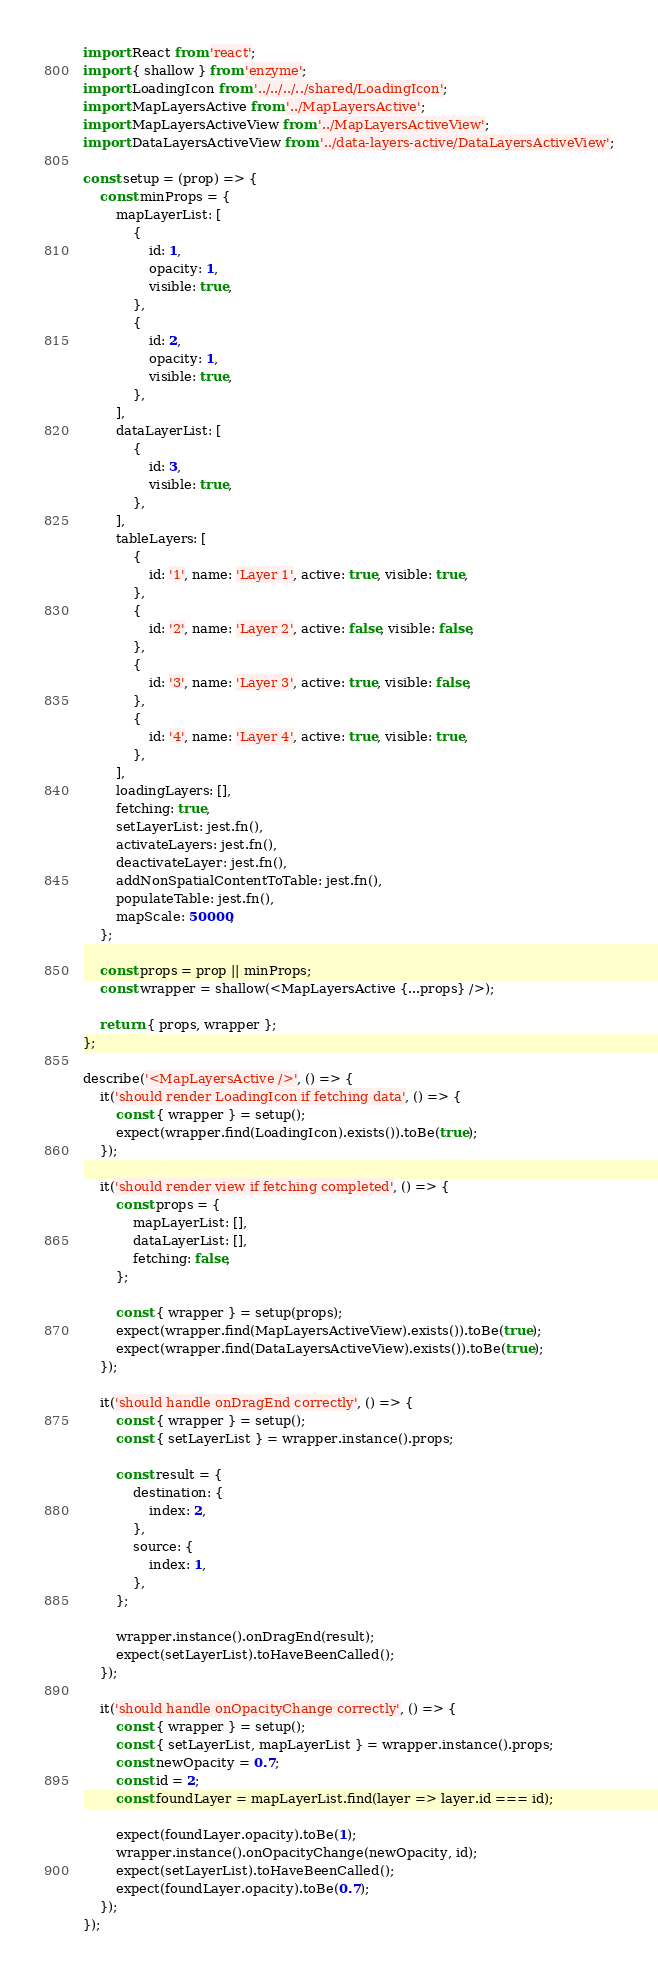<code> <loc_0><loc_0><loc_500><loc_500><_JavaScript_>import React from 'react';
import { shallow } from 'enzyme';
import LoadingIcon from '../../../../shared/LoadingIcon';
import MapLayersActive from '../MapLayersActive';
import MapLayersActiveView from '../MapLayersActiveView';
import DataLayersActiveView from '../data-layers-active/DataLayersActiveView';

const setup = (prop) => {
    const minProps = {
        mapLayerList: [
            {
                id: 1,
                opacity: 1,
                visible: true,
            },
            {
                id: 2,
                opacity: 1,
                visible: true,
            },
        ],
        dataLayerList: [
            {
                id: 3,
                visible: true,
            },
        ],
        tableLayers: [
            {
                id: '1', name: 'Layer 1', active: true, visible: true,
            },
            {
                id: '2', name: 'Layer 2', active: false, visible: false,
            },
            {
                id: '3', name: 'Layer 3', active: true, visible: false,
            },
            {
                id: '4', name: 'Layer 4', active: true, visible: true,
            },
        ],
        loadingLayers: [],
        fetching: true,
        setLayerList: jest.fn(),
        activateLayers: jest.fn(),
        deactivateLayer: jest.fn(),
        addNonSpatialContentToTable: jest.fn(),
        populateTable: jest.fn(),
        mapScale: 50000,
    };

    const props = prop || minProps;
    const wrapper = shallow(<MapLayersActive {...props} />);

    return { props, wrapper };
};

describe('<MapLayersActive />', () => {
    it('should render LoadingIcon if fetching data', () => {
        const { wrapper } = setup();
        expect(wrapper.find(LoadingIcon).exists()).toBe(true);
    });

    it('should render view if fetching completed', () => {
        const props = {
            mapLayerList: [],
            dataLayerList: [],
            fetching: false,
        };

        const { wrapper } = setup(props);
        expect(wrapper.find(MapLayersActiveView).exists()).toBe(true);
        expect(wrapper.find(DataLayersActiveView).exists()).toBe(true);
    });

    it('should handle onDragEnd correctly', () => {
        const { wrapper } = setup();
        const { setLayerList } = wrapper.instance().props;

        const result = {
            destination: {
                index: 2,
            },
            source: {
                index: 1,
            },
        };

        wrapper.instance().onDragEnd(result);
        expect(setLayerList).toHaveBeenCalled();
    });

    it('should handle onOpacityChange correctly', () => {
        const { wrapper } = setup();
        const { setLayerList, mapLayerList } = wrapper.instance().props;
        const newOpacity = 0.7;
        const id = 2;
        const foundLayer = mapLayerList.find(layer => layer.id === id);

        expect(foundLayer.opacity).toBe(1);
        wrapper.instance().onOpacityChange(newOpacity, id);
        expect(setLayerList).toHaveBeenCalled();
        expect(foundLayer.opacity).toBe(0.7);
    });
});
</code> 